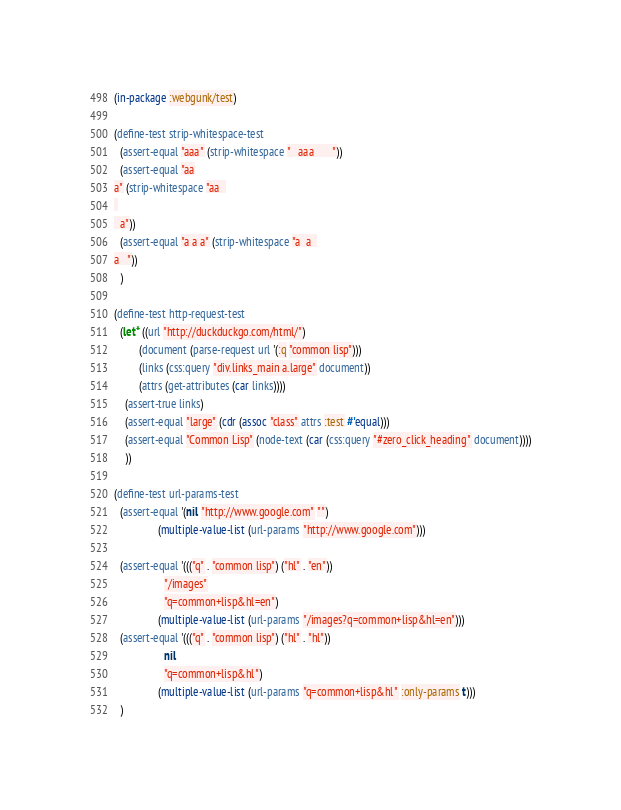<code> <loc_0><loc_0><loc_500><loc_500><_Lisp_>(in-package :webgunk/test)

(define-test strip-whitespace-test
  (assert-equal "aaa" (strip-whitespace "   aaa       "))
  (assert-equal "aa
a" (strip-whitespace "aa  
 
  a"))
  (assert-equal "a a a" (strip-whitespace "a  a  
a   "))
  )

(define-test http-request-test
  (let* ((url "http://duckduckgo.com/html/")
         (document (parse-request url '(:q "common lisp")))
         (links (css:query "div.links_main a.large" document))
         (attrs (get-attributes (car links))))
    (assert-true links)
    (assert-equal "large" (cdr (assoc "class" attrs :test #'equal)))
    (assert-equal "Common Lisp" (node-text (car (css:query "#zero_click_heading" document))))
    ))

(define-test url-params-test
  (assert-equal '(nil "http://www.google.com" "")
                (multiple-value-list (url-params "http://www.google.com")))

  (assert-equal '((("q" . "common lisp") ("hl" . "en"))
                  "/images"
                  "q=common+lisp&hl=en")
                (multiple-value-list (url-params "/images?q=common+lisp&hl=en")))
  (assert-equal '((("q" . "common lisp") ("hl" . "hl"))
                  nil
                  "q=common+lisp&hl")
                (multiple-value-list (url-params "q=common+lisp&hl" :only-params t)))
  )

</code> 